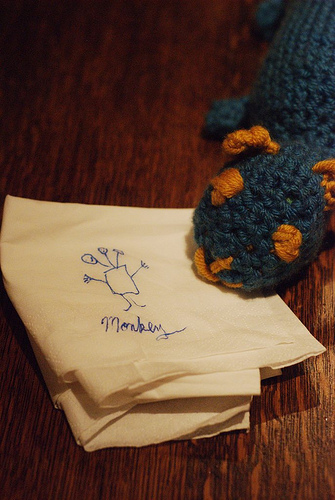<image>
Is there a napkin on the toy? No. The napkin is not positioned on the toy. They may be near each other, but the napkin is not supported by or resting on top of the toy. 